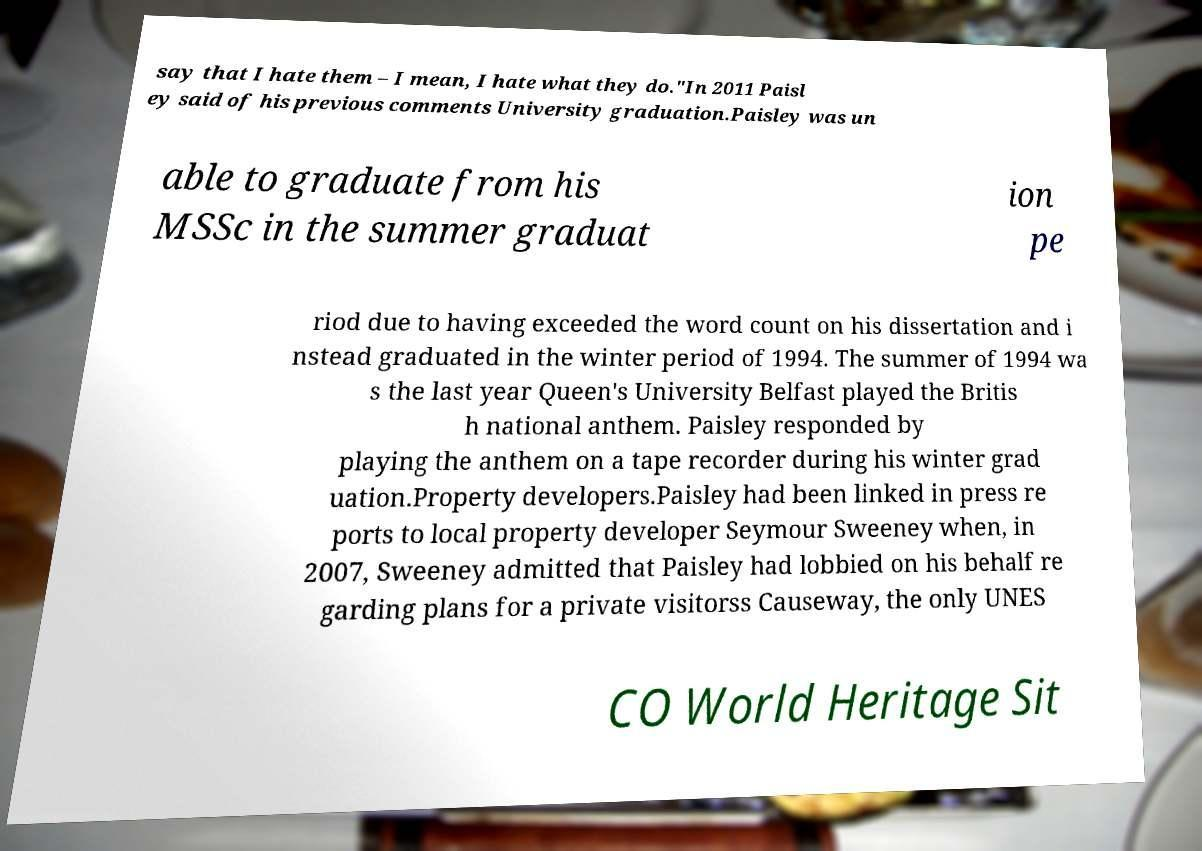Please identify and transcribe the text found in this image. say that I hate them – I mean, I hate what they do."In 2011 Paisl ey said of his previous comments University graduation.Paisley was un able to graduate from his MSSc in the summer graduat ion pe riod due to having exceeded the word count on his dissertation and i nstead graduated in the winter period of 1994. The summer of 1994 wa s the last year Queen's University Belfast played the Britis h national anthem. Paisley responded by playing the anthem on a tape recorder during his winter grad uation.Property developers.Paisley had been linked in press re ports to local property developer Seymour Sweeney when, in 2007, Sweeney admitted that Paisley had lobbied on his behalf re garding plans for a private visitorss Causeway, the only UNES CO World Heritage Sit 